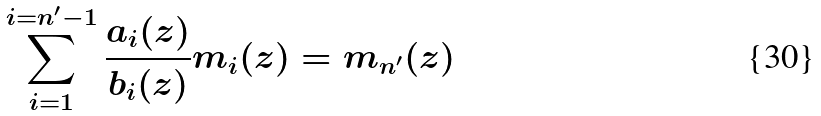Convert formula to latex. <formula><loc_0><loc_0><loc_500><loc_500>\sum _ { i = 1 } ^ { i = n ^ { \prime } - 1 } \frac { a _ { i } ( z ) } { b _ { i } ( z ) } m _ { i } ( z ) = m _ { n ^ { \prime } } ( z )</formula> 